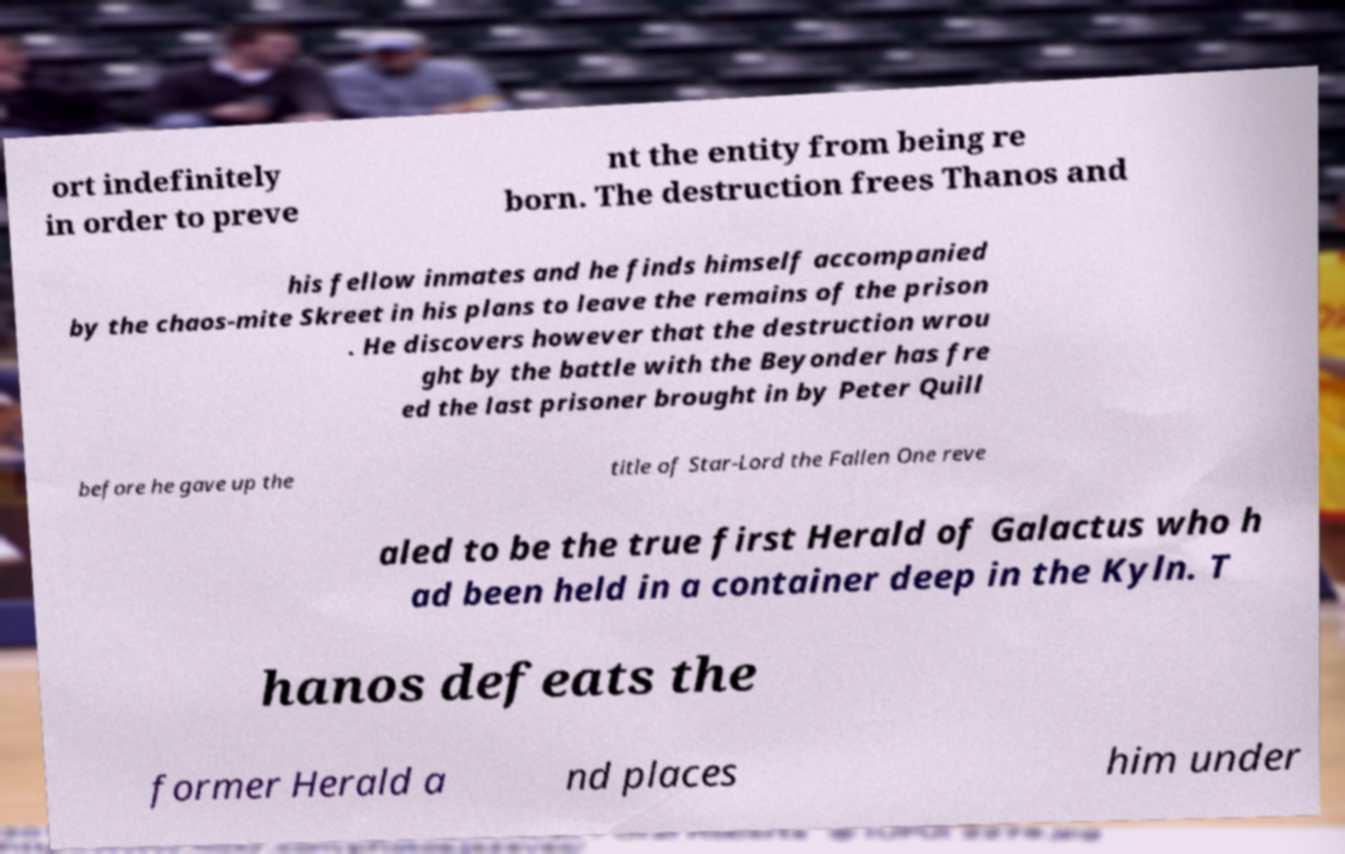Could you assist in decoding the text presented in this image and type it out clearly? ort indefinitely in order to preve nt the entity from being re born. The destruction frees Thanos and his fellow inmates and he finds himself accompanied by the chaos-mite Skreet in his plans to leave the remains of the prison . He discovers however that the destruction wrou ght by the battle with the Beyonder has fre ed the last prisoner brought in by Peter Quill before he gave up the title of Star-Lord the Fallen One reve aled to be the true first Herald of Galactus who h ad been held in a container deep in the Kyln. T hanos defeats the former Herald a nd places him under 